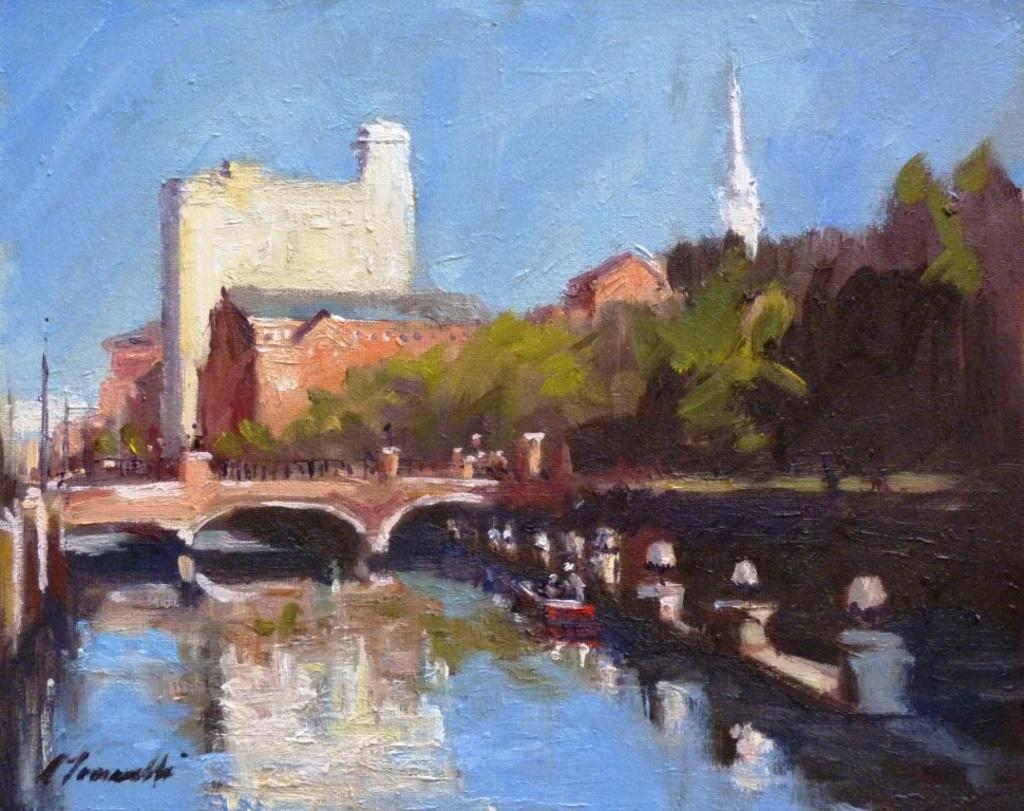What type of artwork is depicted in the image? The image is a painting. What natural feature can be seen in the painting? There is a lake in the painting. What man-made structure is present in the painting? There is a bridge in the painting. What type of vegetation is in the painting? There are trees in the painting. What type of buildings are in the painting? There are buildings in the painting. What tall structure is in the painting? There is a tower in the painting. What mode of transportation is on the water in the painting? There is a boat on the surface of the water in the painting. How many noses can be seen on the boat in the painting? There are no noses present on the boat in the painting, as boats do not have noses. What type of lock is used to secure the tower in the painting? There is no lock present in the painting, as the focus is on the tower's appearance rather than its security features. 